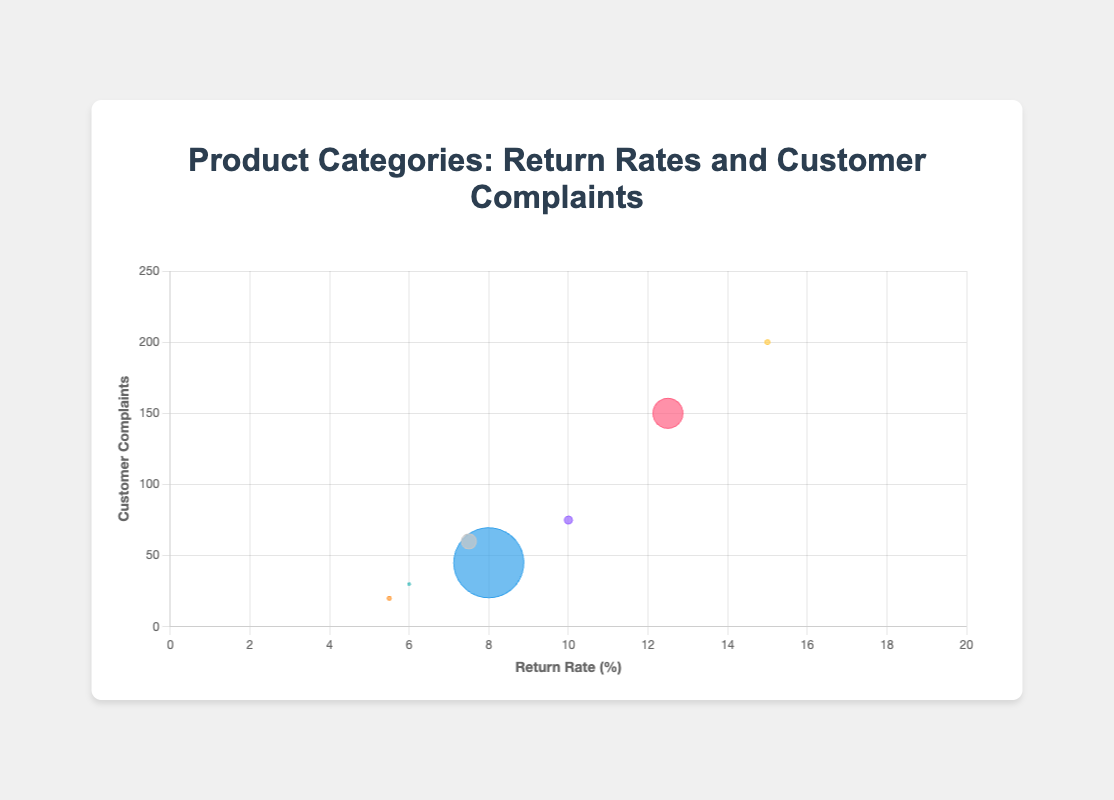what is the category with the highest return rate? The category with the highest return rate can be determined by finding the point farthest along the x-axis. "Clothing" has a return rate of 15.0%, which is the highest among all categories.
Answer: Clothing how many customer complaints does "Furniture" have? Locate the bubble labeled "Furniture" and find its position on the y-axis, which represents customer complaints. "Furniture" has 45 customer complaints.
Answer: 45 which category has the largest bubble size and what does it represent? The largest bubble represents "Furniture." The size of the bubble corresponds to the average price, and "Furniture" has the highest average price of $700 among the categories.
Answer: Furniture, average price which category has a lower return rate, "Footwear" or "Sports Equipment"? Compare the x-axis positions of the bubbles labeled "Footwear" and "Sports Equipment." "Sports Equipment" has a return rate of 7.5%, which is lower than "Footwear"'s return rate of 10.0%.
Answer: Sports Equipment what is the relationship between customer complaints and return rates for "Electronics" and "Footwear"? Compare the x and y positions of "Electronics" and "Footwear." While "Electronics" has a higher return rate (12.5%) compared to "Footwear" (10.0%), it also has more customer complaints (150) relative to "Footwear" (75). Therefore, "Electronics" shows higher values in both metrics.
Answer: Electronics has higher values in both metrics which product category has the fewest customer complaints? Locate the bubble with the lowest position on the y-axis. "Home Decor" has the fewest customer complaints at 20.
Answer: Home Decor is there a category with both a return rate below 10% and fewer than 50 customer complaints? Find the bubbles where both the x value is less than 10 and the y value is less than 50. "Furniture" (return rate 8.0%, customer complaints 45) and "Home Decor" (return rate 5.5%, customer complaints 20) meet these criteria.
Answer: Furniture and Home Decor how do the return rates for "Toys" and "Home Decor" compare? Check the x-axis positions of bubbles labeled "Toys" and "Home Decor." "Toys" has a return rate of 6.0%, and "Home Decor" has a return rate of 5.5%. "Home Decor" has a slightly lower return rate.
Answer: Home Decor which category has the highest average price, and how is it represented visually? Look for the largest bubble on the chart, because the bubble size represents the average price. "Furniture" has the highest average price ($700), represented by the largest bubble.
Answer: Furniture what is the sum of customer complaints for "Electronics" and "Clothing"? Add the y values of "Electronics" (150) and "Clothing" (200) to get the total customer complaints. 150 + 200 = 350 customer complaints.
Answer: 350 